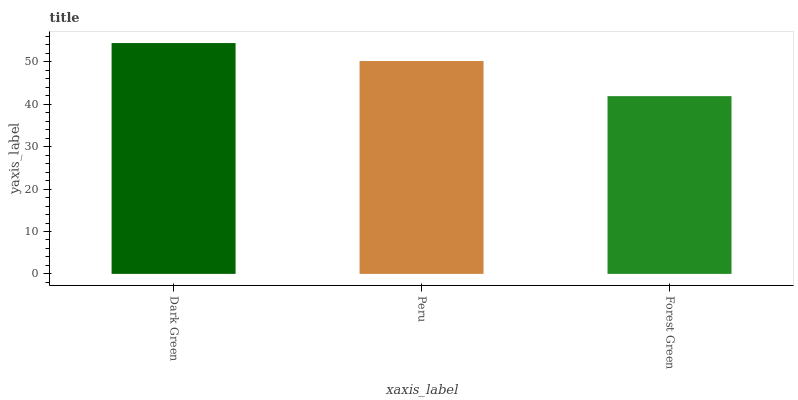Is Forest Green the minimum?
Answer yes or no. Yes. Is Dark Green the maximum?
Answer yes or no. Yes. Is Peru the minimum?
Answer yes or no. No. Is Peru the maximum?
Answer yes or no. No. Is Dark Green greater than Peru?
Answer yes or no. Yes. Is Peru less than Dark Green?
Answer yes or no. Yes. Is Peru greater than Dark Green?
Answer yes or no. No. Is Dark Green less than Peru?
Answer yes or no. No. Is Peru the high median?
Answer yes or no. Yes. Is Peru the low median?
Answer yes or no. Yes. Is Forest Green the high median?
Answer yes or no. No. Is Forest Green the low median?
Answer yes or no. No. 